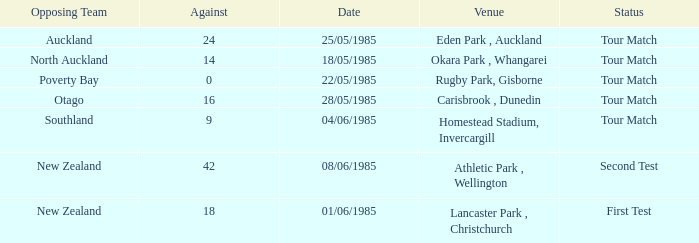Which opposing team had an Against score less than 42 and a Tour Match status in Rugby Park, Gisborne? Poverty Bay. 